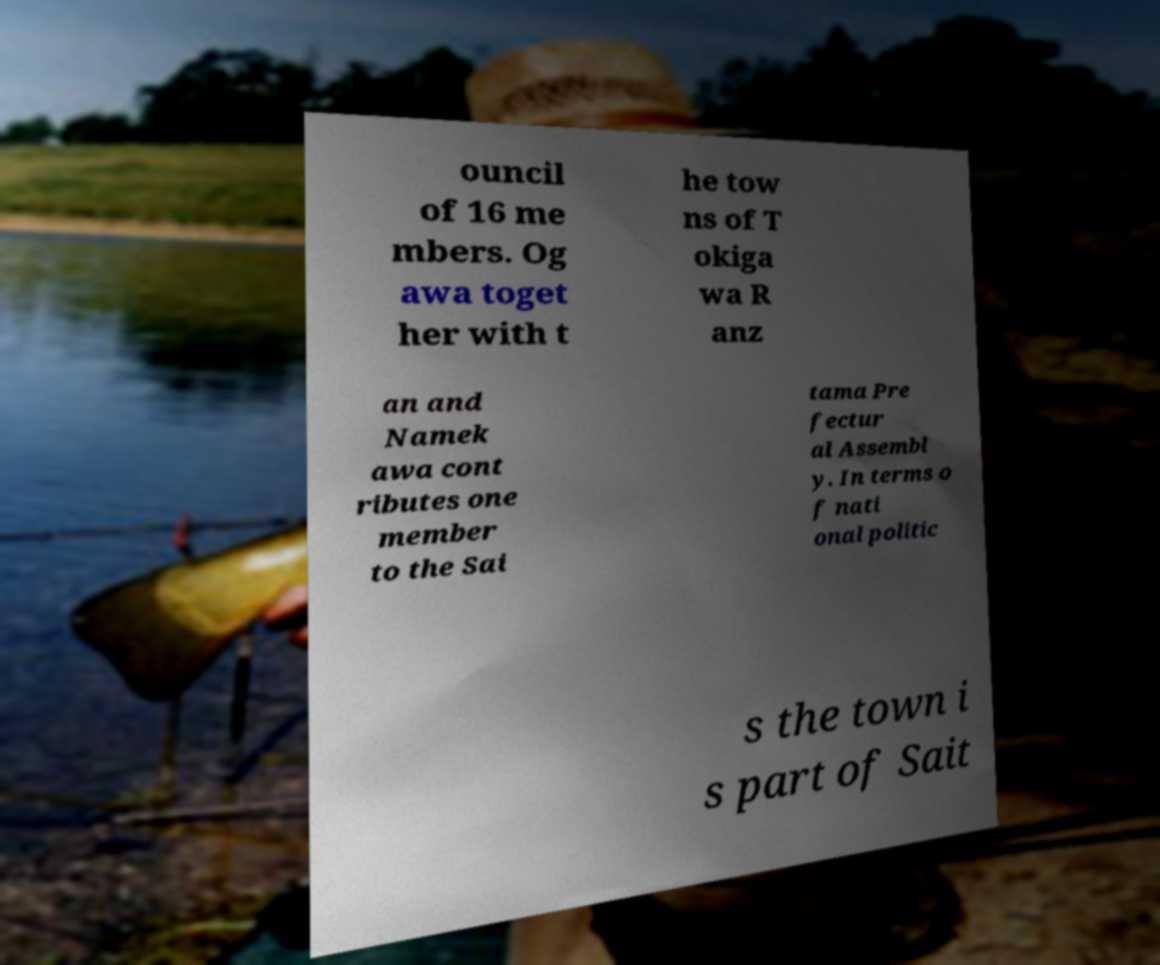Can you accurately transcribe the text from the provided image for me? ouncil of 16 me mbers. Og awa toget her with t he tow ns of T okiga wa R anz an and Namek awa cont ributes one member to the Sai tama Pre fectur al Assembl y. In terms o f nati onal politic s the town i s part of Sait 